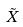Convert formula to latex. <formula><loc_0><loc_0><loc_500><loc_500>\tilde { X }</formula> 